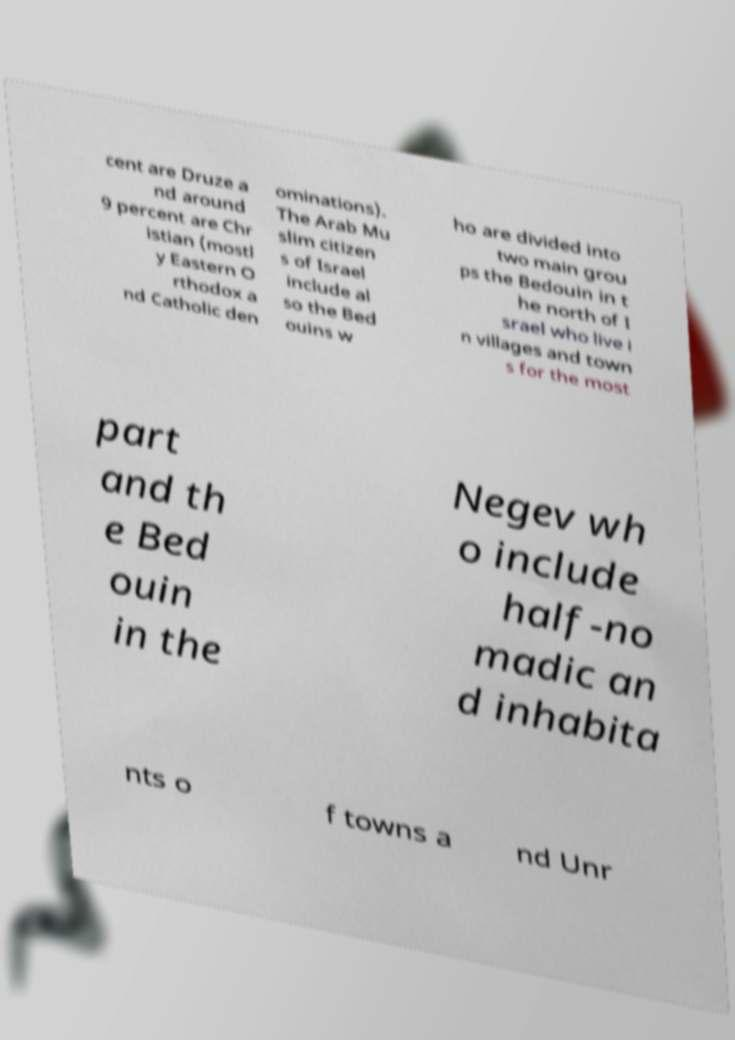What messages or text are displayed in this image? I need them in a readable, typed format. cent are Druze a nd around 9 percent are Chr istian (mostl y Eastern O rthodox a nd Catholic den ominations). The Arab Mu slim citizen s of Israel include al so the Bed ouins w ho are divided into two main grou ps the Bedouin in t he north of I srael who live i n villages and town s for the most part and th e Bed ouin in the Negev wh o include half-no madic an d inhabita nts o f towns a nd Unr 